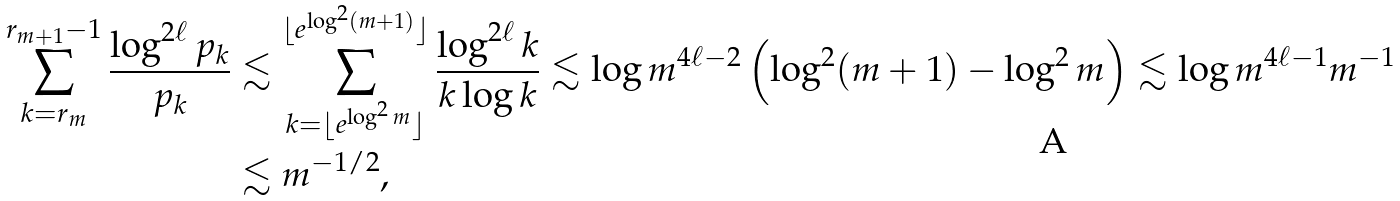Convert formula to latex. <formula><loc_0><loc_0><loc_500><loc_500>\sum _ { k = r _ { m } } ^ { r _ { m + 1 } - 1 } \frac { \log ^ { 2 \ell } p _ { k } } { p _ { k } } & \lesssim \sum _ { k = \lfloor e ^ { \log ^ { 2 } m } \rfloor } ^ { \lfloor e ^ { \log ^ { 2 } ( m + 1 ) } \rfloor } \frac { \log ^ { 2 \ell } k } { k \log k } \lesssim \log m ^ { 4 \ell - 2 } \left ( \log ^ { 2 } ( m + 1 ) - \log ^ { 2 } m \right ) \lesssim \log m ^ { 4 \ell - 1 } m ^ { - 1 } \\ & \lesssim m ^ { - 1 / 2 } ,</formula> 